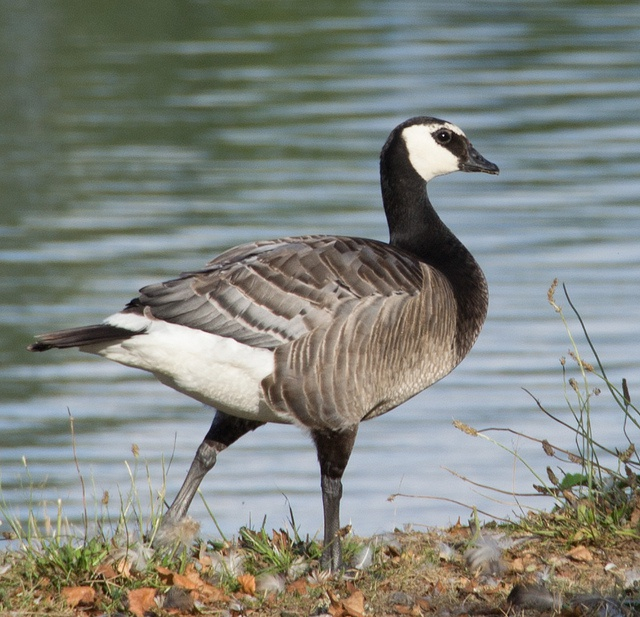Describe the objects in this image and their specific colors. I can see a bird in gray, darkgray, black, and lightgray tones in this image. 